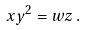<formula> <loc_0><loc_0><loc_500><loc_500>x y ^ { 2 } = w z \, .</formula> 